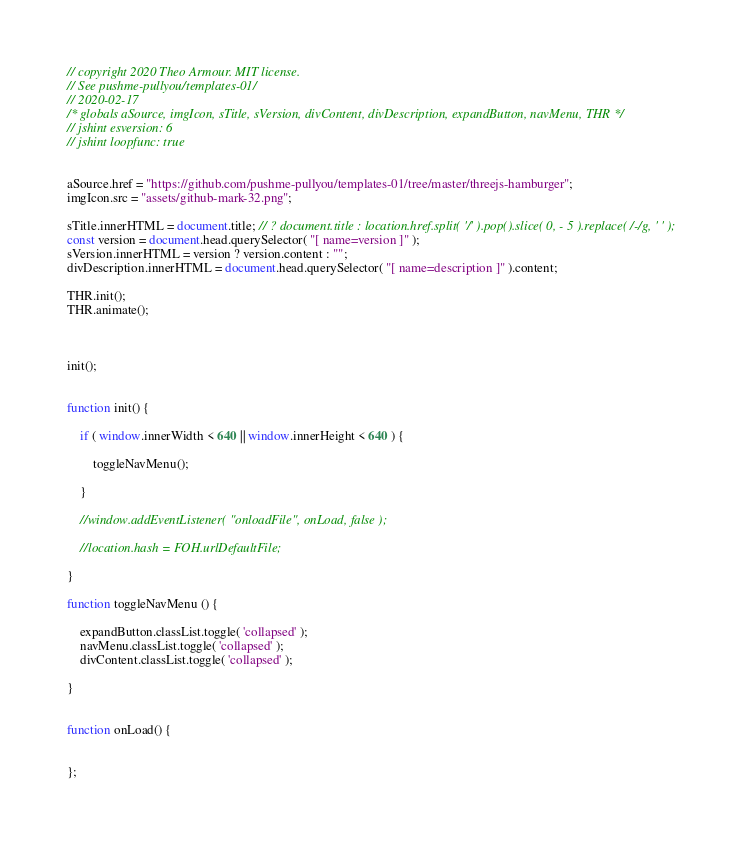<code> <loc_0><loc_0><loc_500><loc_500><_JavaScript_>// copyright 2020 Theo Armour. MIT license.
// See pushme-pullyou/templates-01/
// 2020-02-17
/* globals aSource, imgIcon, sTitle, sVersion, divContent, divDescription, expandButton, navMenu, THR */
// jshint esversion: 6
// jshint loopfunc: true


aSource.href = "https://github.com/pushme-pullyou/templates-01/tree/master/threejs-hamburger";
imgIcon.src = "assets/github-mark-32.png";

sTitle.innerHTML = document.title; // ? document.title : location.href.split( '/' ).pop().slice( 0, - 5 ).replace( /-/g, ' ' );
const version = document.head.querySelector( "[ name=version ]" );
sVersion.innerHTML = version ? version.content : "";
divDescription.innerHTML = document.head.querySelector( "[ name=description ]" ).content;

THR.init();
THR.animate();



init();


function init() {

	if ( window.innerWidth < 640 || window.innerHeight < 640 ) {

		toggleNavMenu();

	}

	//window.addEventListener( "onloadFile", onLoad, false );

	//location.hash = FOH.urlDefaultFile;

}

function toggleNavMenu () {

	expandButton.classList.toggle( 'collapsed' );
	navMenu.classList.toggle( 'collapsed' );
	divContent.classList.toggle( 'collapsed' );

}


function onLoad() {


};
</code> 